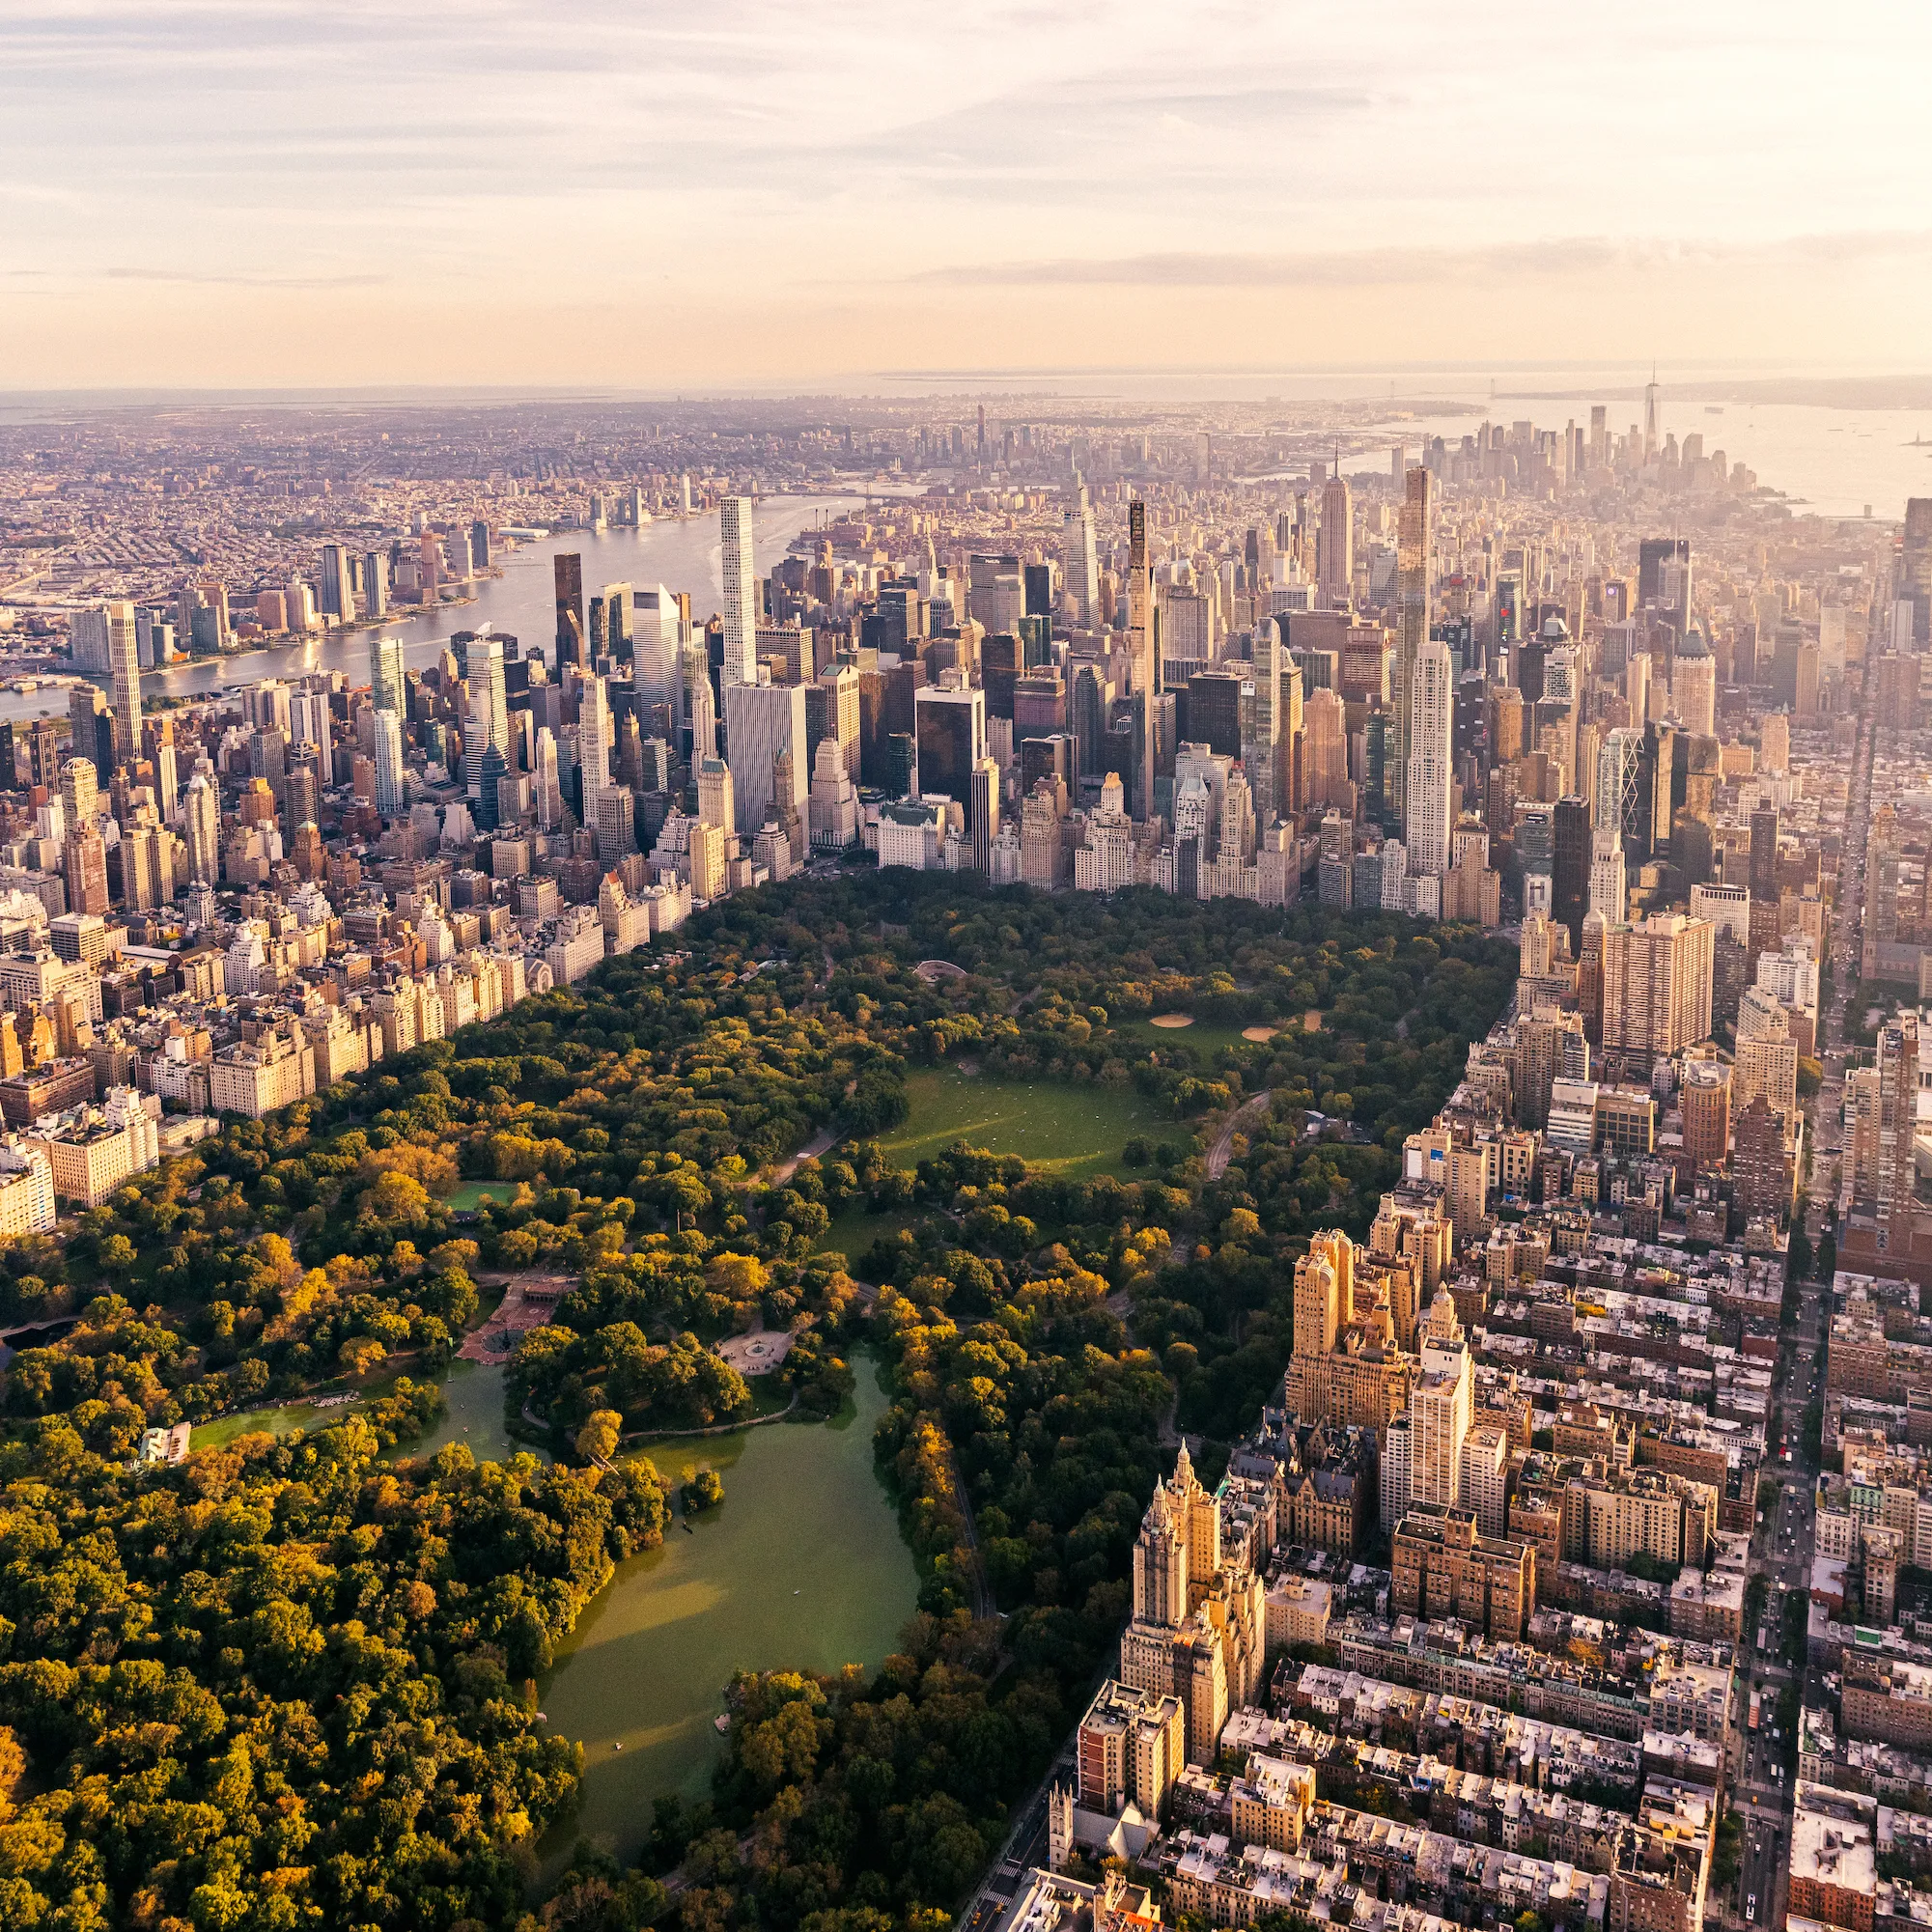Can you describe the main features of this image for me? The photograph presents an aerial view of Central Park in New York City during the late hours of the afternoon, as indicated by the golden hues of the setting sun. Central Park acts as a tranquil heart in the midst of the bustling urban environment that surrounds it. The large, reflective lake visible in the center is known as the Jacqueline Kennedy Onassis Reservoir, a significant water body that adds to the park's picturesque landscape. Surrounding the park are numerous notable skyscrapers, contributing to an impressive skyline that includes historic and contemporary architectural styles. This view not only highlights the park's natural beauty and its contrast with the urban surroundings but also illustrates its role as a vital green space for urban dwellers. 